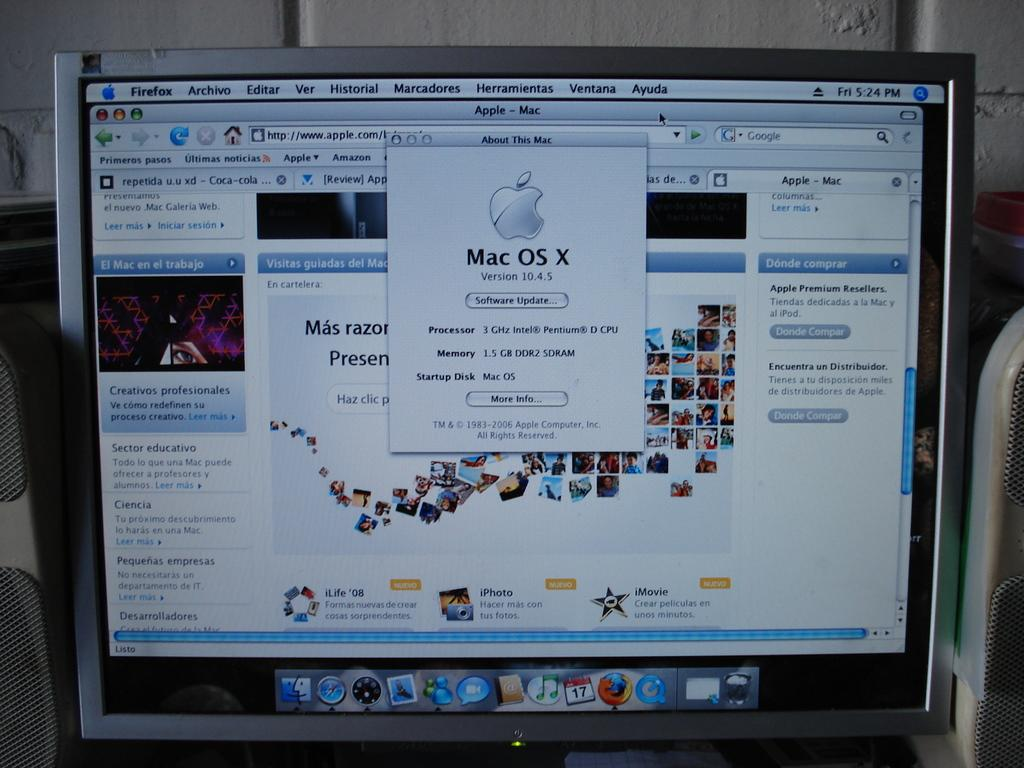Where was the image taken? The image is taken indoors. What electronic device can be seen in the image? There is a monitor in the image. Are there any audio devices present in the image? Yes, there are speaker boxes in the image. What is displayed on the monitor's screen? The monitor's screen displays pictures and text. Can you see any fairies dancing on the seashore in the image? No, there are no fairies or seashore present in the image; it is an indoor setting with electronic devices. 